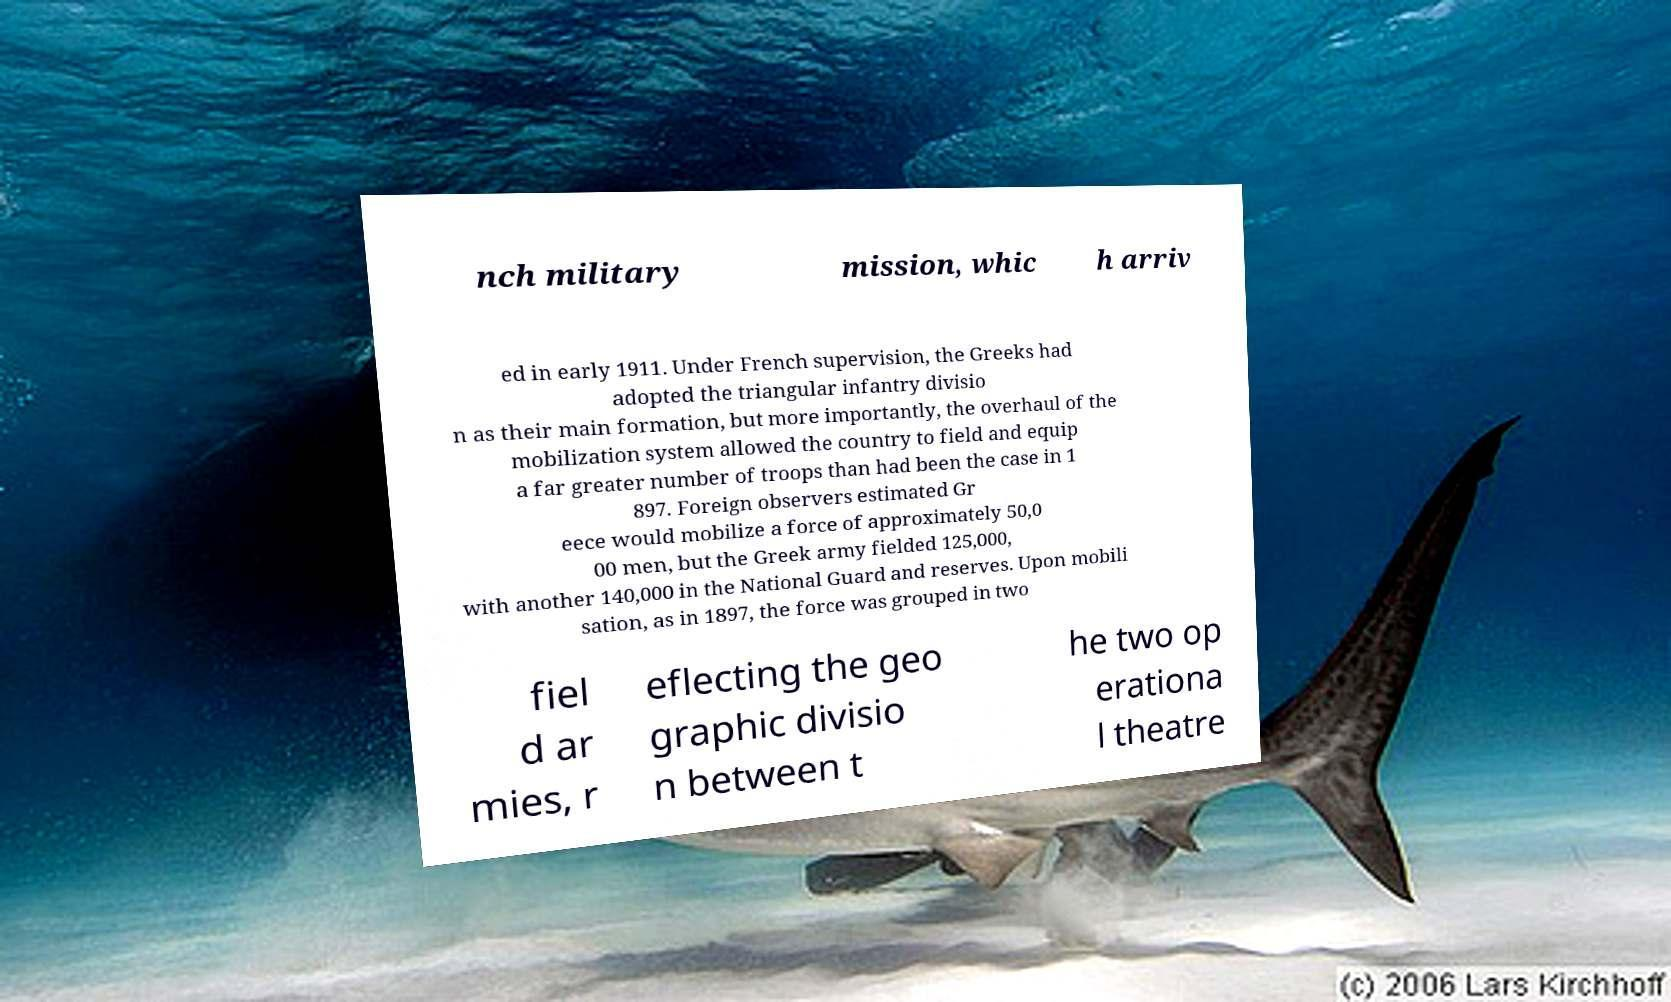Can you read and provide the text displayed in the image?This photo seems to have some interesting text. Can you extract and type it out for me? nch military mission, whic h arriv ed in early 1911. Under French supervision, the Greeks had adopted the triangular infantry divisio n as their main formation, but more importantly, the overhaul of the mobilization system allowed the country to field and equip a far greater number of troops than had been the case in 1 897. Foreign observers estimated Gr eece would mobilize a force of approximately 50,0 00 men, but the Greek army fielded 125,000, with another 140,000 in the National Guard and reserves. Upon mobili sation, as in 1897, the force was grouped in two fiel d ar mies, r eflecting the geo graphic divisio n between t he two op erationa l theatre 